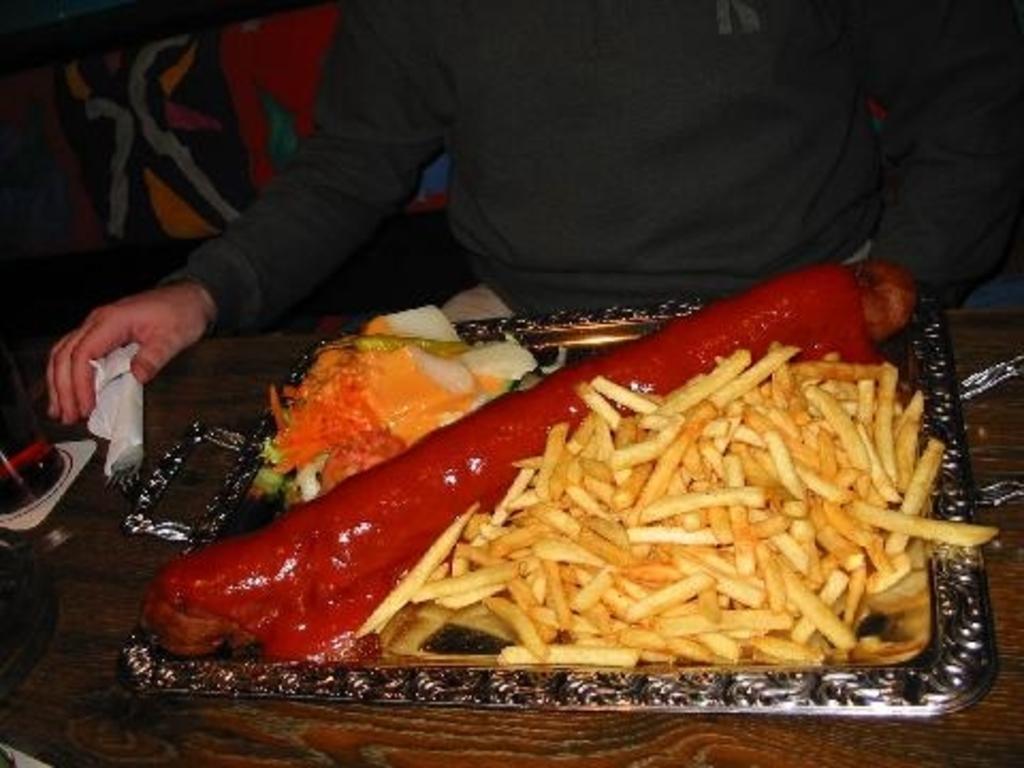Please provide a concise description of this image. There are french fries and other food items in a plate on the table and we can also see a glass,fork and tissue paper on the left side on the table and there is a person at the table. In the background on the left side there are objects. 